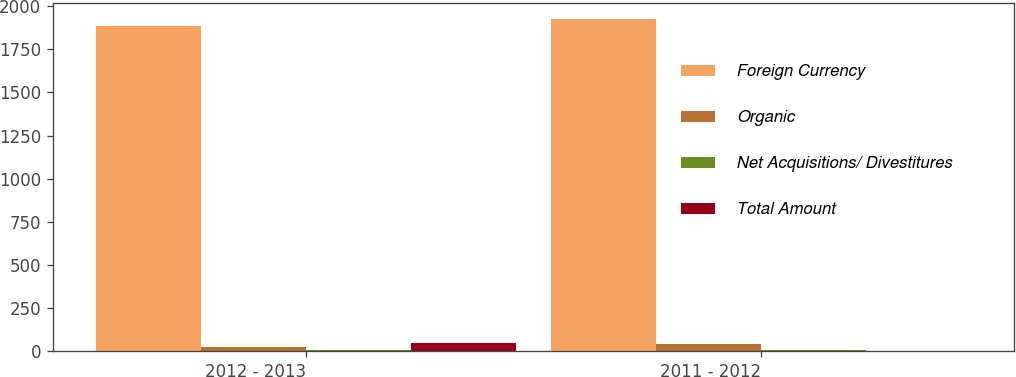<chart> <loc_0><loc_0><loc_500><loc_500><stacked_bar_chart><ecel><fcel>2012 - 2013<fcel>2011 - 2012<nl><fcel>Foreign Currency<fcel>1887.2<fcel>1924.3<nl><fcel>Organic<fcel>27.3<fcel>40.7<nl><fcel>Net Acquisitions/ Divestitures<fcel>10.2<fcel>8.4<nl><fcel>Total Amount<fcel>47.8<fcel>4.8<nl></chart> 